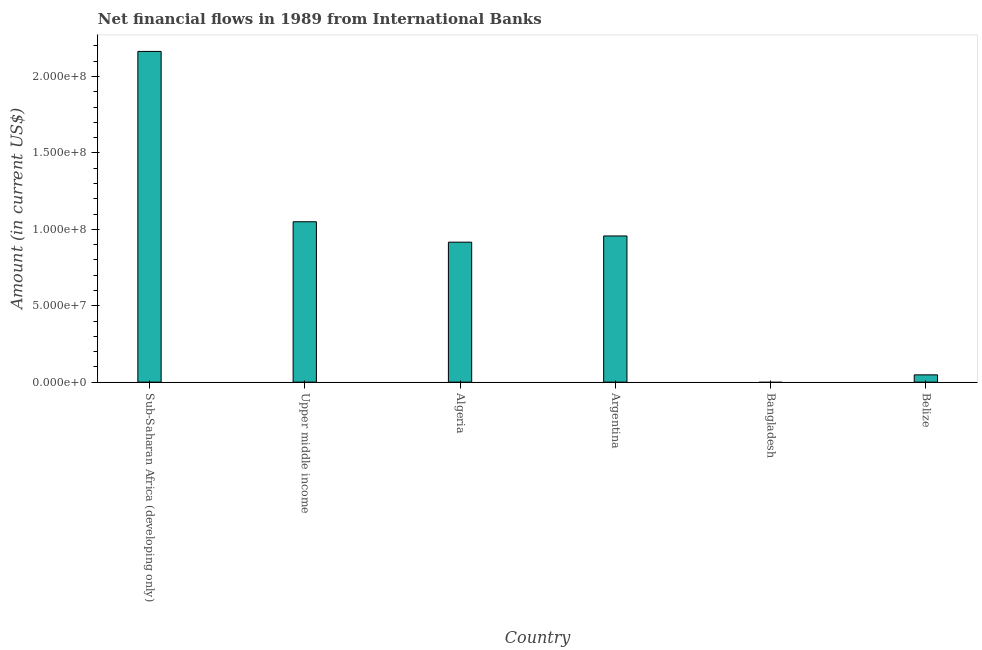What is the title of the graph?
Keep it short and to the point. Net financial flows in 1989 from International Banks. What is the label or title of the X-axis?
Offer a terse response. Country. What is the label or title of the Y-axis?
Your answer should be very brief. Amount (in current US$). What is the net financial flows from ibrd in Argentina?
Ensure brevity in your answer.  9.56e+07. Across all countries, what is the maximum net financial flows from ibrd?
Offer a terse response. 2.16e+08. In which country was the net financial flows from ibrd maximum?
Offer a terse response. Sub-Saharan Africa (developing only). What is the sum of the net financial flows from ibrd?
Keep it short and to the point. 5.13e+08. What is the difference between the net financial flows from ibrd in Algeria and Upper middle income?
Ensure brevity in your answer.  -1.34e+07. What is the average net financial flows from ibrd per country?
Your answer should be compact. 8.56e+07. What is the median net financial flows from ibrd?
Your answer should be compact. 9.36e+07. What is the ratio of the net financial flows from ibrd in Algeria to that in Argentina?
Your answer should be very brief. 0.96. Is the difference between the net financial flows from ibrd in Algeria and Belize greater than the difference between any two countries?
Offer a very short reply. No. What is the difference between the highest and the second highest net financial flows from ibrd?
Your answer should be very brief. 1.11e+08. What is the difference between the highest and the lowest net financial flows from ibrd?
Ensure brevity in your answer.  2.16e+08. How many bars are there?
Your response must be concise. 5. How many countries are there in the graph?
Keep it short and to the point. 6. What is the difference between two consecutive major ticks on the Y-axis?
Make the answer very short. 5.00e+07. What is the Amount (in current US$) of Sub-Saharan Africa (developing only)?
Keep it short and to the point. 2.16e+08. What is the Amount (in current US$) of Upper middle income?
Keep it short and to the point. 1.05e+08. What is the Amount (in current US$) of Algeria?
Ensure brevity in your answer.  9.16e+07. What is the Amount (in current US$) of Argentina?
Provide a succinct answer. 9.56e+07. What is the Amount (in current US$) in Belize?
Your response must be concise. 4.76e+06. What is the difference between the Amount (in current US$) in Sub-Saharan Africa (developing only) and Upper middle income?
Ensure brevity in your answer.  1.11e+08. What is the difference between the Amount (in current US$) in Sub-Saharan Africa (developing only) and Algeria?
Give a very brief answer. 1.25e+08. What is the difference between the Amount (in current US$) in Sub-Saharan Africa (developing only) and Argentina?
Keep it short and to the point. 1.21e+08. What is the difference between the Amount (in current US$) in Sub-Saharan Africa (developing only) and Belize?
Your answer should be very brief. 2.12e+08. What is the difference between the Amount (in current US$) in Upper middle income and Algeria?
Keep it short and to the point. 1.34e+07. What is the difference between the Amount (in current US$) in Upper middle income and Argentina?
Your answer should be very brief. 9.29e+06. What is the difference between the Amount (in current US$) in Upper middle income and Belize?
Your answer should be very brief. 1.00e+08. What is the difference between the Amount (in current US$) in Algeria and Argentina?
Ensure brevity in your answer.  -4.06e+06. What is the difference between the Amount (in current US$) in Algeria and Belize?
Keep it short and to the point. 8.68e+07. What is the difference between the Amount (in current US$) in Argentina and Belize?
Make the answer very short. 9.09e+07. What is the ratio of the Amount (in current US$) in Sub-Saharan Africa (developing only) to that in Upper middle income?
Your response must be concise. 2.06. What is the ratio of the Amount (in current US$) in Sub-Saharan Africa (developing only) to that in Algeria?
Make the answer very short. 2.36. What is the ratio of the Amount (in current US$) in Sub-Saharan Africa (developing only) to that in Argentina?
Keep it short and to the point. 2.26. What is the ratio of the Amount (in current US$) in Sub-Saharan Africa (developing only) to that in Belize?
Your answer should be compact. 45.42. What is the ratio of the Amount (in current US$) in Upper middle income to that in Algeria?
Keep it short and to the point. 1.15. What is the ratio of the Amount (in current US$) in Upper middle income to that in Argentina?
Ensure brevity in your answer.  1.1. What is the ratio of the Amount (in current US$) in Upper middle income to that in Belize?
Provide a short and direct response. 22.03. What is the ratio of the Amount (in current US$) in Algeria to that in Argentina?
Your answer should be very brief. 0.96. What is the ratio of the Amount (in current US$) in Algeria to that in Belize?
Provide a succinct answer. 19.22. What is the ratio of the Amount (in current US$) in Argentina to that in Belize?
Make the answer very short. 20.08. 